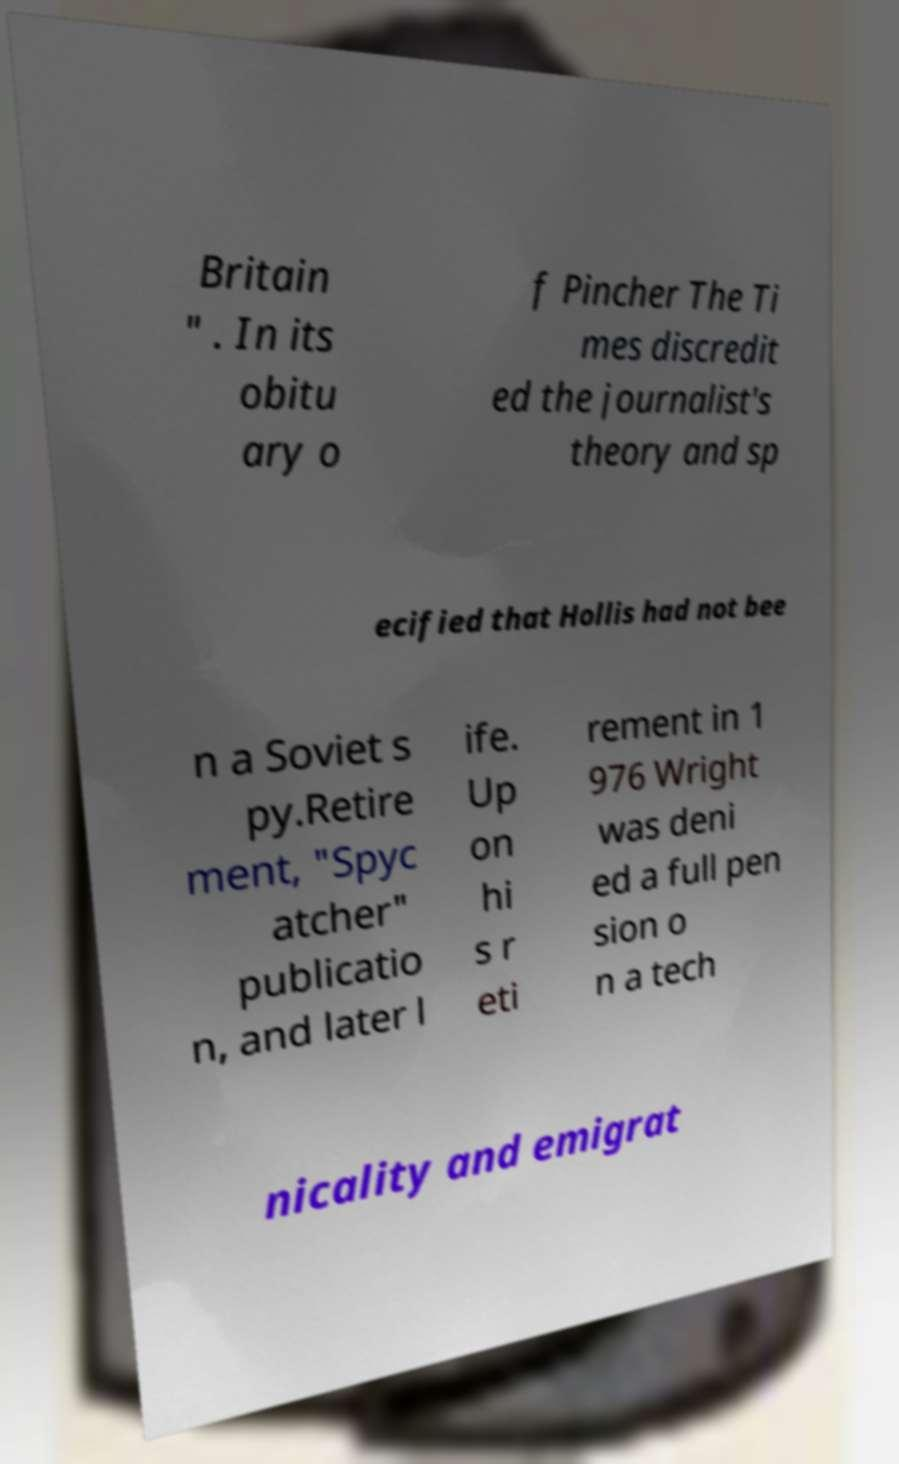For documentation purposes, I need the text within this image transcribed. Could you provide that? Britain " . In its obitu ary o f Pincher The Ti mes discredit ed the journalist's theory and sp ecified that Hollis had not bee n a Soviet s py.Retire ment, "Spyc atcher" publicatio n, and later l ife. Up on hi s r eti rement in 1 976 Wright was deni ed a full pen sion o n a tech nicality and emigrat 